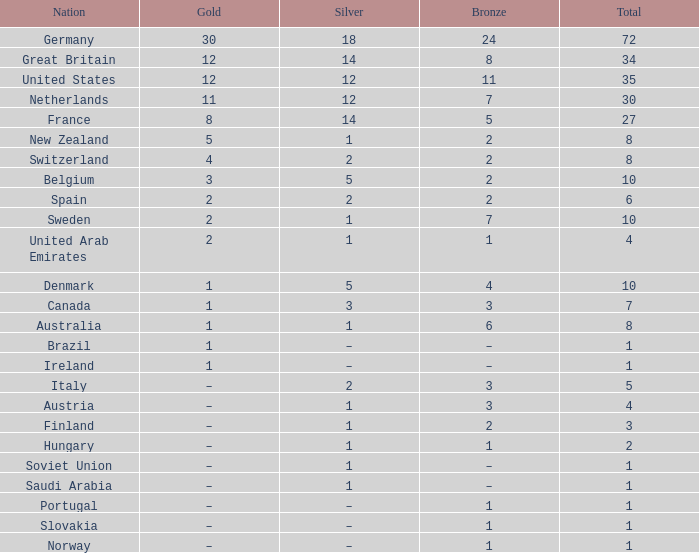What is Gold, when Silver is 5, and when Nation is Belgium? 3.0. 